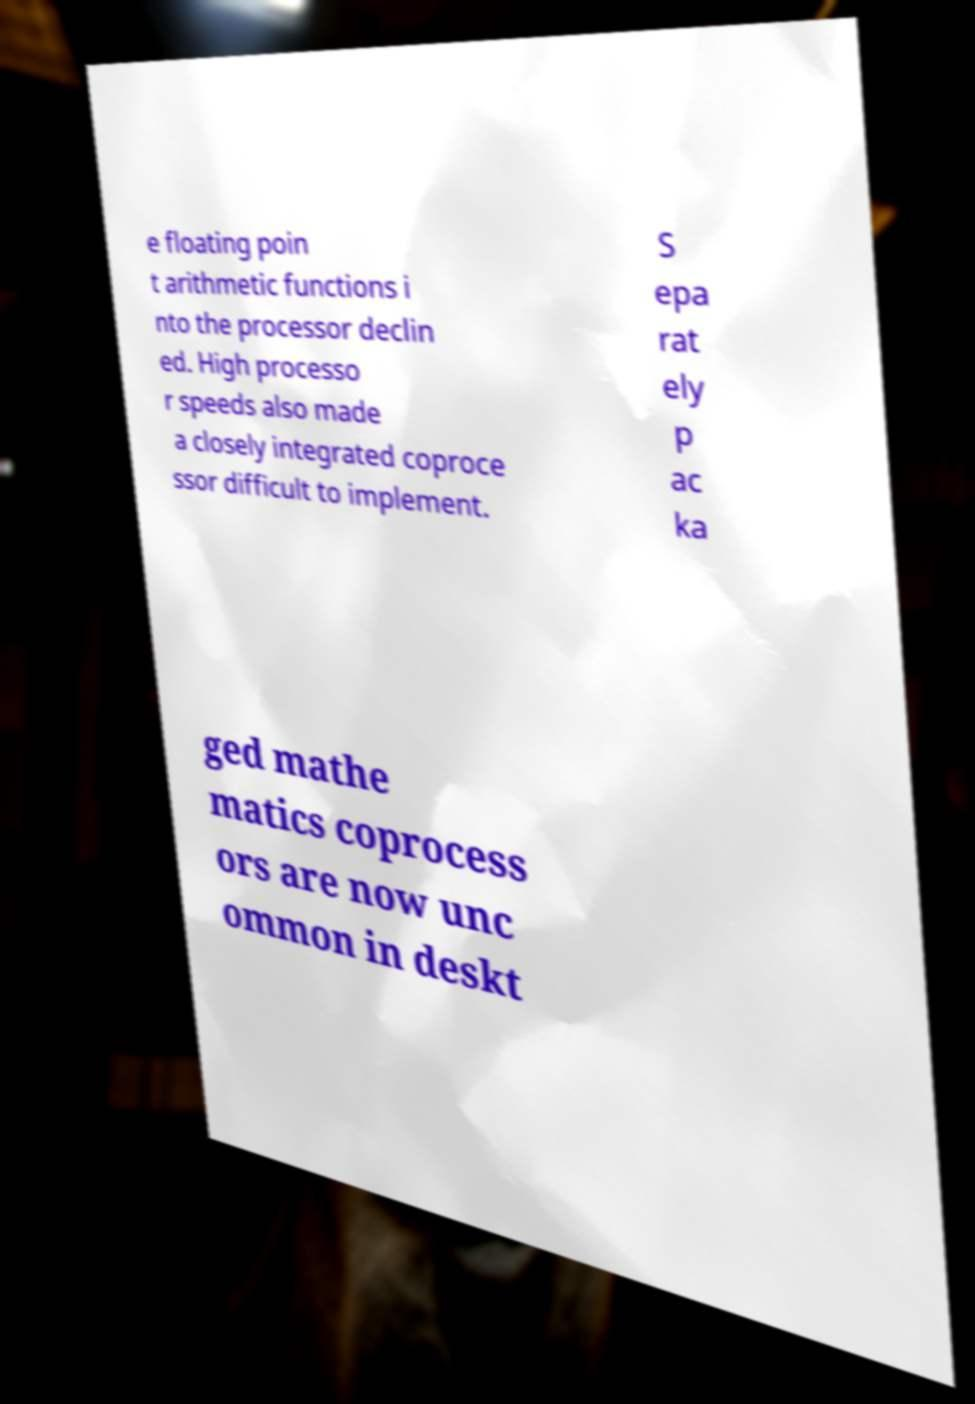There's text embedded in this image that I need extracted. Can you transcribe it verbatim? e floating poin t arithmetic functions i nto the processor declin ed. High processo r speeds also made a closely integrated coproce ssor difficult to implement. S epa rat ely p ac ka ged mathe matics coprocess ors are now unc ommon in deskt 